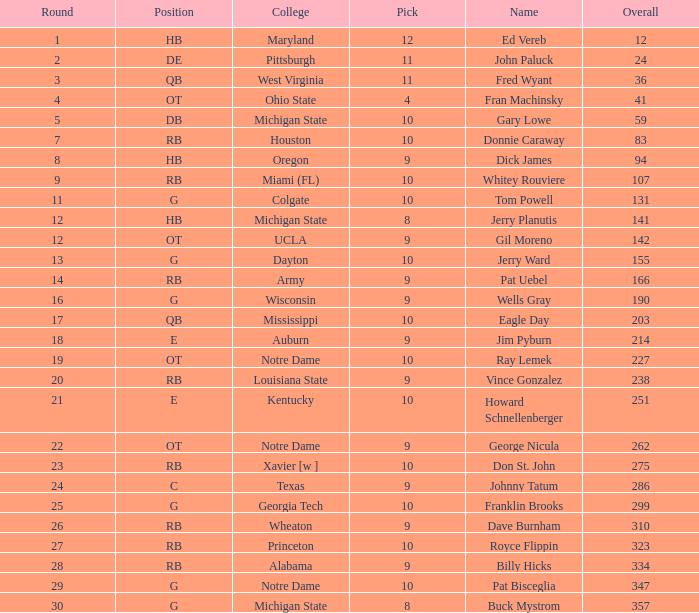What is the total number of overall picks that were after pick 9 and went to Auburn College? 0.0. 